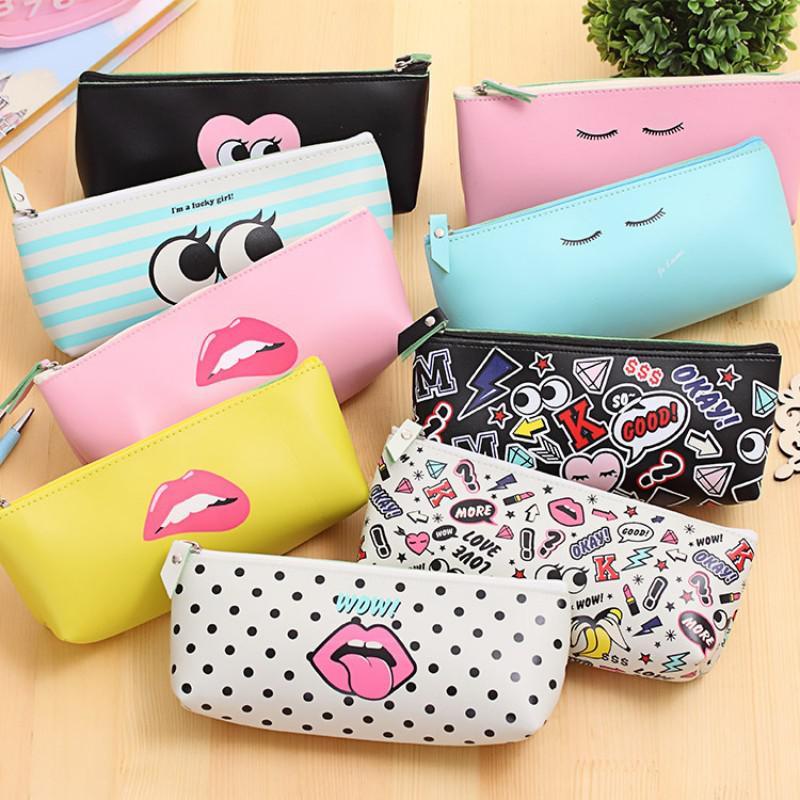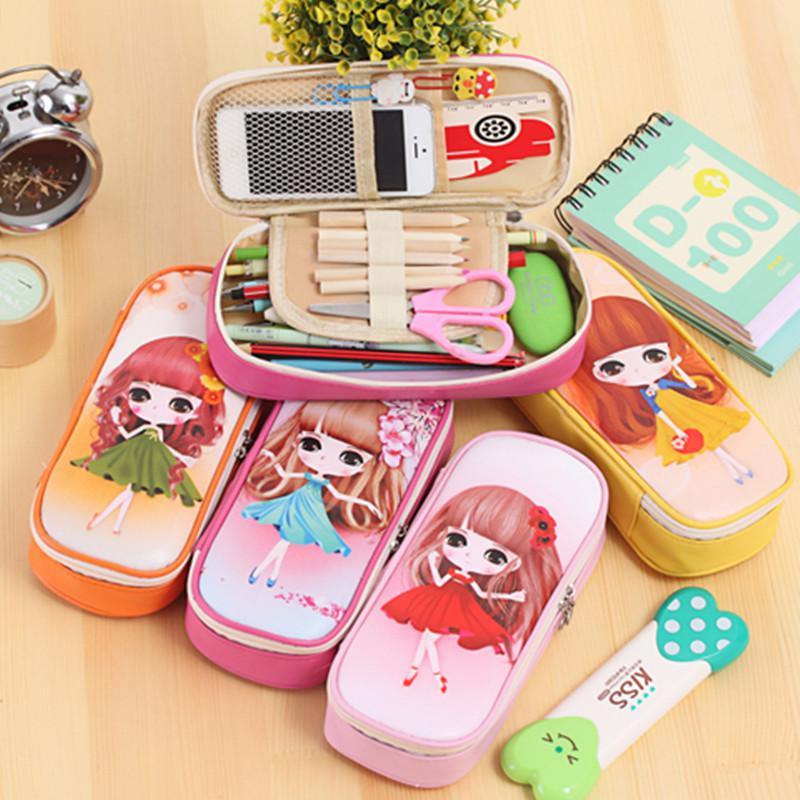The first image is the image on the left, the second image is the image on the right. Evaluate the accuracy of this statement regarding the images: "The open pouch in one of the images contains an electronic device.". Is it true? Answer yes or no. Yes. 